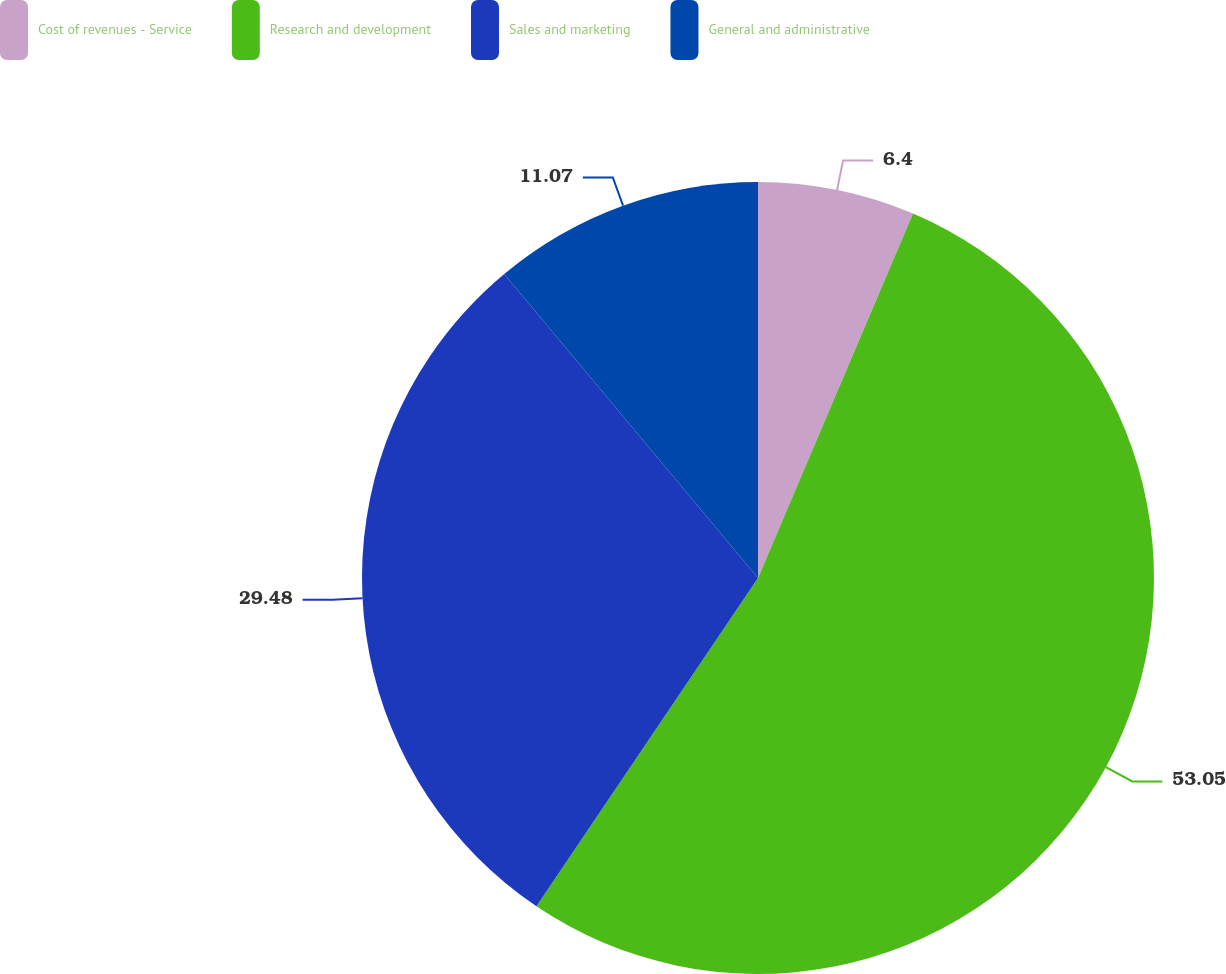Convert chart to OTSL. <chart><loc_0><loc_0><loc_500><loc_500><pie_chart><fcel>Cost of revenues - Service<fcel>Research and development<fcel>Sales and marketing<fcel>General and administrative<nl><fcel>6.4%<fcel>53.05%<fcel>29.48%<fcel>11.07%<nl></chart> 